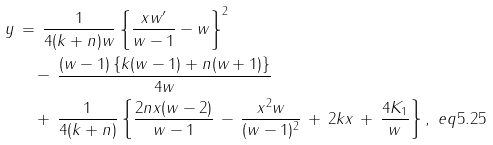<formula> <loc_0><loc_0><loc_500><loc_500>y & \, = \, \frac { 1 } { 4 ( k + n ) w } \left \{ \frac { x w ^ { \prime } } { w - 1 } - w \right \} ^ { 2 } \\ & \quad \null \, - \, \frac { ( w - 1 ) \left \{ k ( w - 1 ) + n ( w + 1 ) \right \} } { 4 w } \\ & \quad \null \, + \, \frac { 1 } { 4 ( k + n ) } \left \{ \frac { 2 n x ( w - 2 ) } { w - 1 } \, - \, \frac { x ^ { 2 } w } { ( w - 1 ) ^ { 2 } } \, + \, 2 k x \, + \, \frac { 4 K _ { 1 } } { w } \right \} , \ e q { 5 . 2 5 }</formula> 